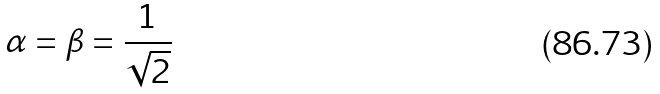Convert formula to latex. <formula><loc_0><loc_0><loc_500><loc_500>\alpha = \beta = \frac { 1 } { \sqrt { 2 } }</formula> 